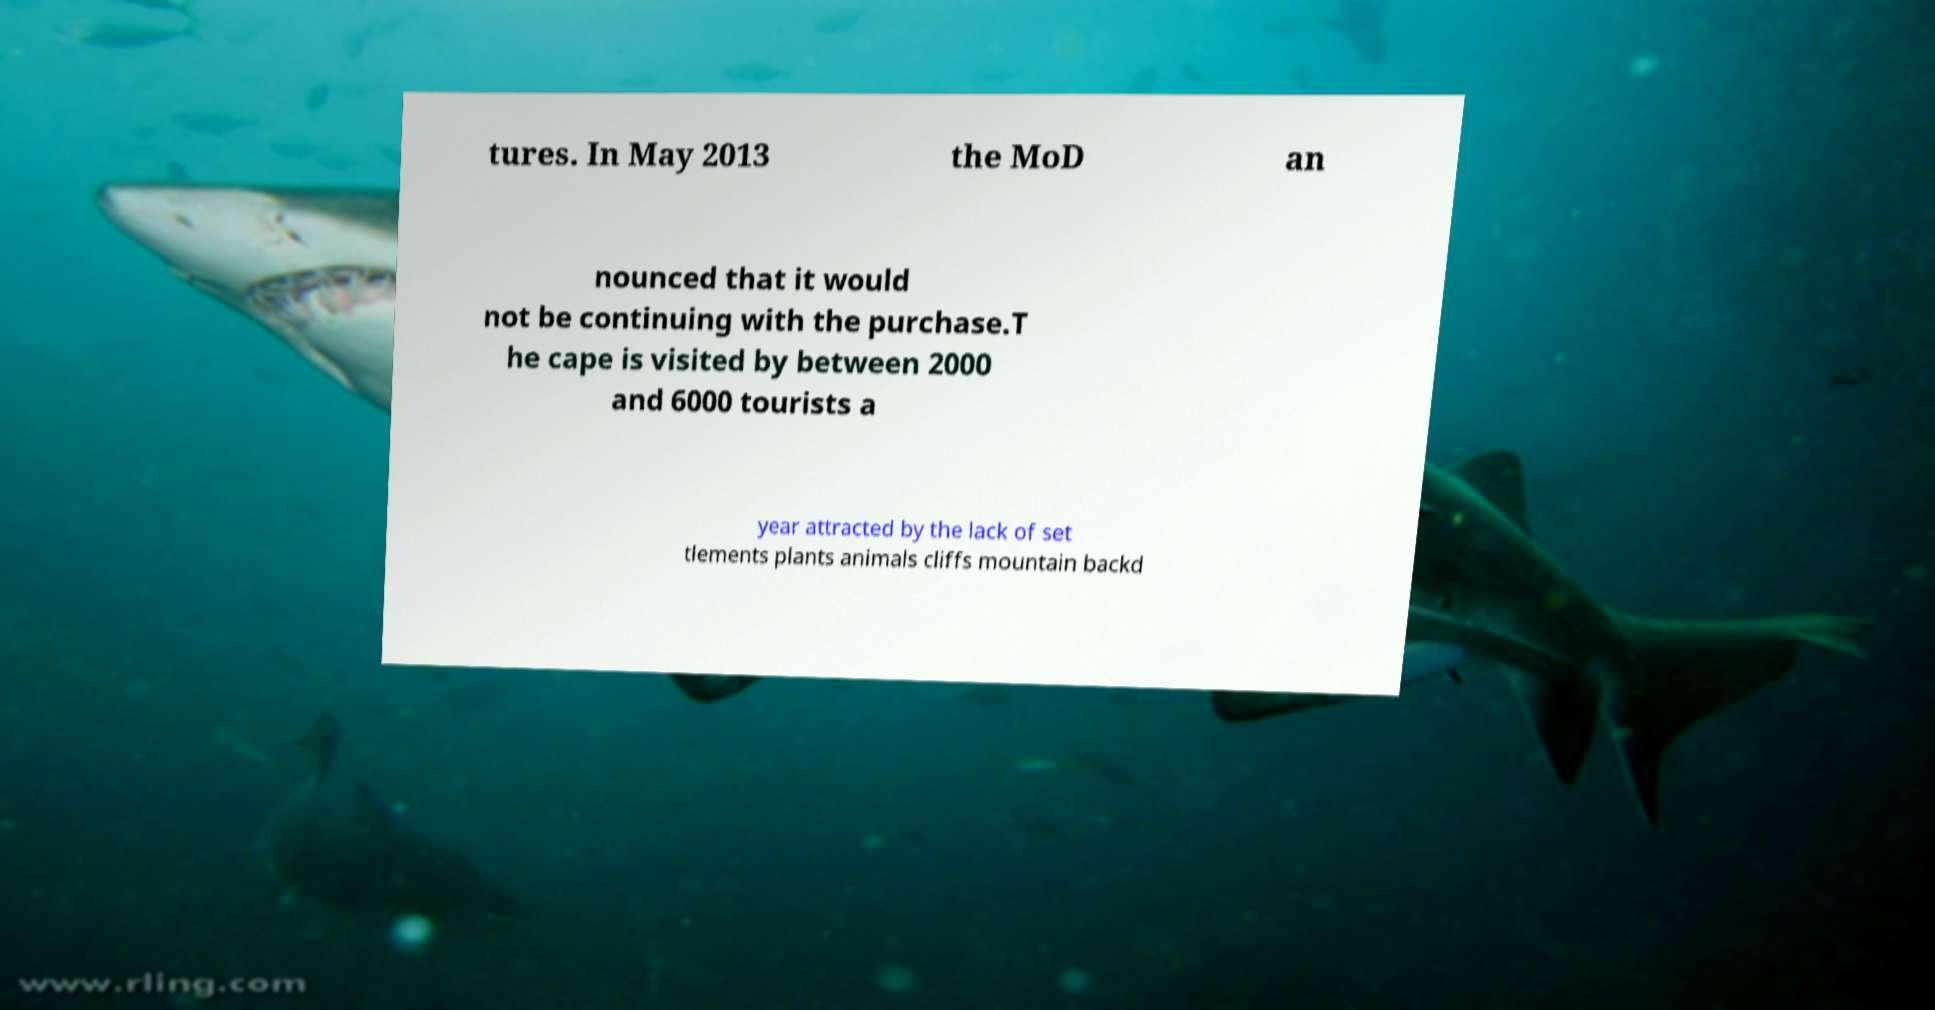Could you assist in decoding the text presented in this image and type it out clearly? tures. In May 2013 the MoD an nounced that it would not be continuing with the purchase.T he cape is visited by between 2000 and 6000 tourists a year attracted by the lack of set tlements plants animals cliffs mountain backd 